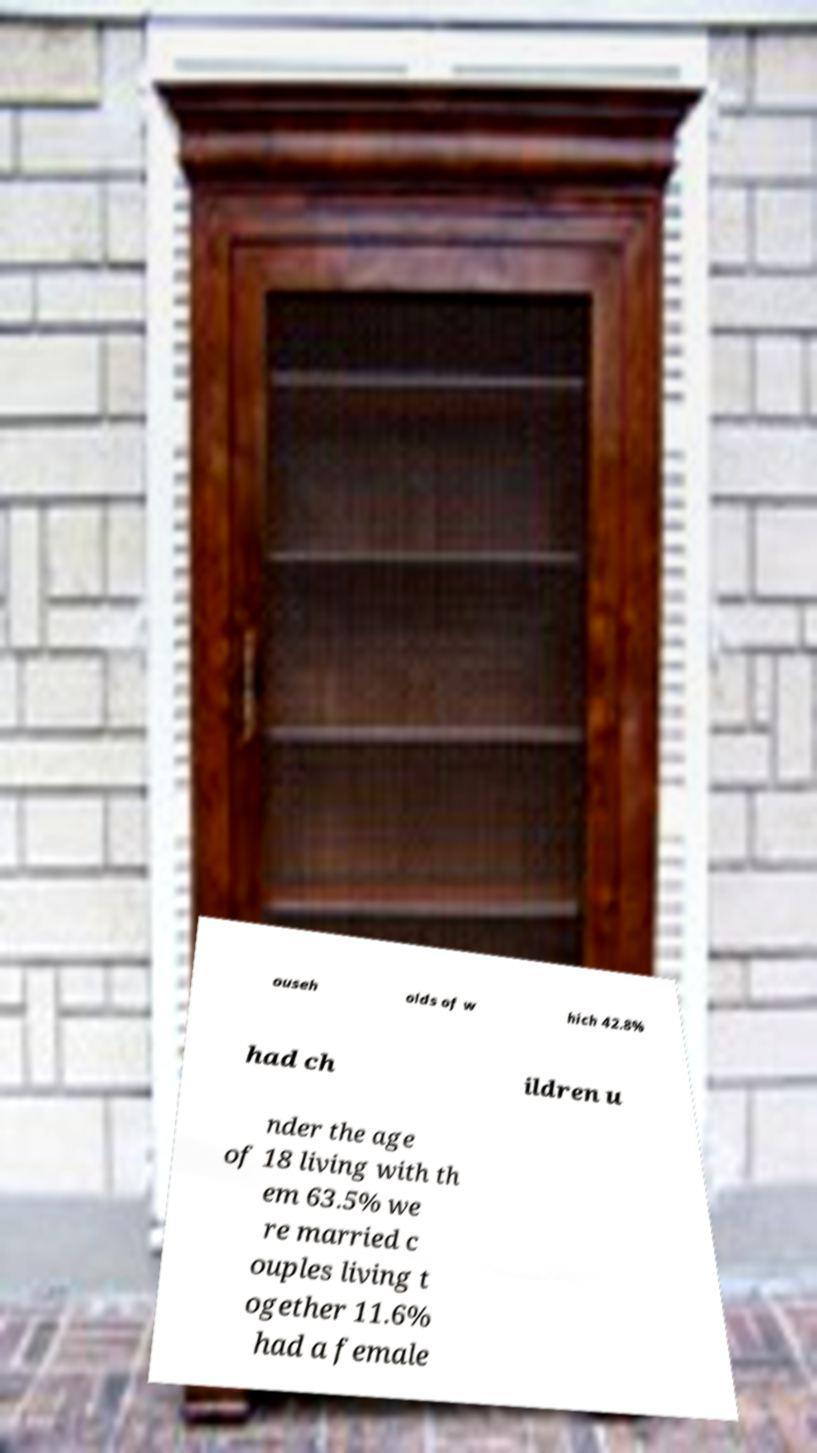What messages or text are displayed in this image? I need them in a readable, typed format. ouseh olds of w hich 42.8% had ch ildren u nder the age of 18 living with th em 63.5% we re married c ouples living t ogether 11.6% had a female 